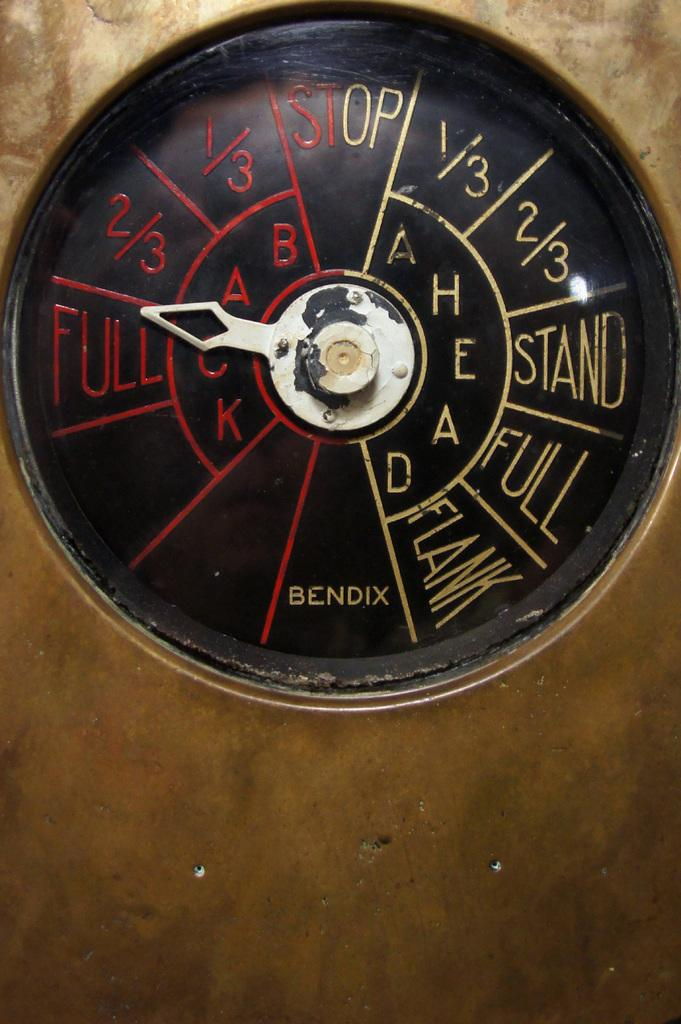Provide a one-sentence caption for the provided image. A gauge with an arrow points to Full on the left side. 